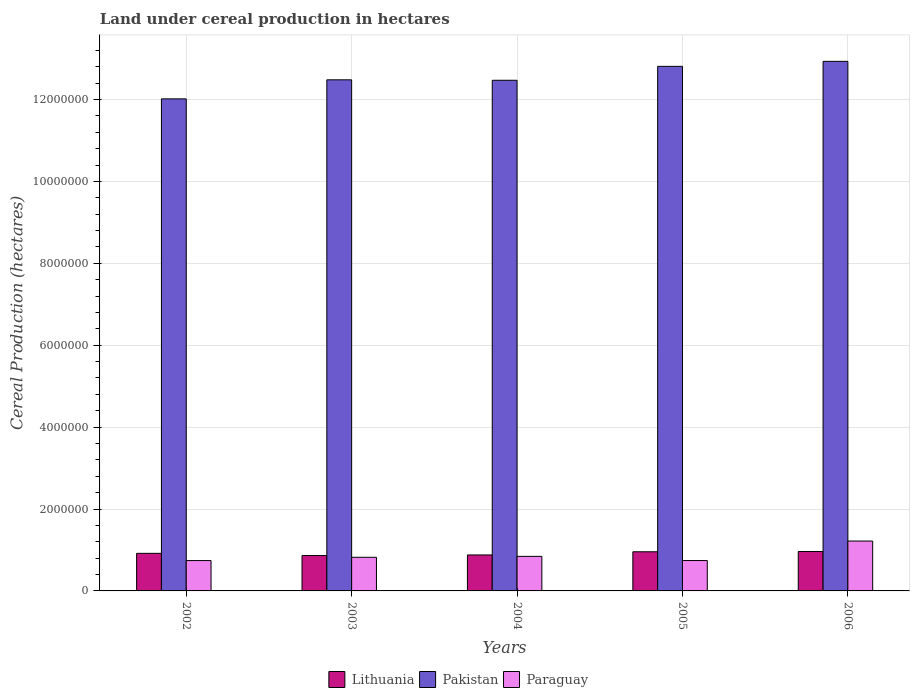How many different coloured bars are there?
Give a very brief answer. 3. How many bars are there on the 3rd tick from the left?
Provide a short and direct response. 3. In how many cases, is the number of bars for a given year not equal to the number of legend labels?
Your response must be concise. 0. What is the land under cereal production in Lithuania in 2002?
Your response must be concise. 9.18e+05. Across all years, what is the maximum land under cereal production in Paraguay?
Your answer should be very brief. 1.22e+06. Across all years, what is the minimum land under cereal production in Paraguay?
Your answer should be compact. 7.41e+05. In which year was the land under cereal production in Paraguay maximum?
Your answer should be very brief. 2006. What is the total land under cereal production in Pakistan in the graph?
Your response must be concise. 6.27e+07. What is the difference between the land under cereal production in Lithuania in 2004 and that in 2005?
Your answer should be compact. -7.76e+04. What is the difference between the land under cereal production in Lithuania in 2005 and the land under cereal production in Pakistan in 2006?
Make the answer very short. -1.20e+07. What is the average land under cereal production in Lithuania per year?
Offer a terse response. 9.16e+05. In the year 2003, what is the difference between the land under cereal production in Pakistan and land under cereal production in Paraguay?
Offer a very short reply. 1.17e+07. In how many years, is the land under cereal production in Lithuania greater than 12000000 hectares?
Make the answer very short. 0. What is the ratio of the land under cereal production in Pakistan in 2002 to that in 2005?
Your answer should be compact. 0.94. Is the land under cereal production in Pakistan in 2002 less than that in 2006?
Ensure brevity in your answer.  Yes. Is the difference between the land under cereal production in Pakistan in 2005 and 2006 greater than the difference between the land under cereal production in Paraguay in 2005 and 2006?
Provide a short and direct response. Yes. What is the difference between the highest and the second highest land under cereal production in Pakistan?
Give a very brief answer. 1.22e+05. What is the difference between the highest and the lowest land under cereal production in Lithuania?
Ensure brevity in your answer.  9.83e+04. What does the 3rd bar from the right in 2002 represents?
Give a very brief answer. Lithuania. How many years are there in the graph?
Give a very brief answer. 5. Does the graph contain any zero values?
Offer a terse response. No. Does the graph contain grids?
Ensure brevity in your answer.  Yes. How many legend labels are there?
Provide a short and direct response. 3. What is the title of the graph?
Give a very brief answer. Land under cereal production in hectares. Does "United Kingdom" appear as one of the legend labels in the graph?
Provide a succinct answer. No. What is the label or title of the X-axis?
Your answer should be compact. Years. What is the label or title of the Y-axis?
Give a very brief answer. Cereal Production (hectares). What is the Cereal Production (hectares) in Lithuania in 2002?
Ensure brevity in your answer.  9.18e+05. What is the Cereal Production (hectares) of Pakistan in 2002?
Provide a succinct answer. 1.20e+07. What is the Cereal Production (hectares) of Paraguay in 2002?
Keep it short and to the point. 7.41e+05. What is the Cereal Production (hectares) in Lithuania in 2003?
Your answer should be compact. 8.65e+05. What is the Cereal Production (hectares) in Pakistan in 2003?
Provide a succinct answer. 1.25e+07. What is the Cereal Production (hectares) of Paraguay in 2003?
Offer a very short reply. 8.21e+05. What is the Cereal Production (hectares) in Lithuania in 2004?
Provide a succinct answer. 8.78e+05. What is the Cereal Production (hectares) in Pakistan in 2004?
Make the answer very short. 1.25e+07. What is the Cereal Production (hectares) of Paraguay in 2004?
Your answer should be compact. 8.44e+05. What is the Cereal Production (hectares) of Lithuania in 2005?
Provide a succinct answer. 9.56e+05. What is the Cereal Production (hectares) of Pakistan in 2005?
Provide a succinct answer. 1.28e+07. What is the Cereal Production (hectares) of Paraguay in 2005?
Your answer should be very brief. 7.42e+05. What is the Cereal Production (hectares) in Lithuania in 2006?
Give a very brief answer. 9.63e+05. What is the Cereal Production (hectares) of Pakistan in 2006?
Make the answer very short. 1.29e+07. What is the Cereal Production (hectares) of Paraguay in 2006?
Your answer should be very brief. 1.22e+06. Across all years, what is the maximum Cereal Production (hectares) of Lithuania?
Your response must be concise. 9.63e+05. Across all years, what is the maximum Cereal Production (hectares) in Pakistan?
Keep it short and to the point. 1.29e+07. Across all years, what is the maximum Cereal Production (hectares) of Paraguay?
Offer a very short reply. 1.22e+06. Across all years, what is the minimum Cereal Production (hectares) in Lithuania?
Offer a terse response. 8.65e+05. Across all years, what is the minimum Cereal Production (hectares) in Pakistan?
Provide a succinct answer. 1.20e+07. Across all years, what is the minimum Cereal Production (hectares) in Paraguay?
Ensure brevity in your answer.  7.41e+05. What is the total Cereal Production (hectares) of Lithuania in the graph?
Keep it short and to the point. 4.58e+06. What is the total Cereal Production (hectares) in Pakistan in the graph?
Give a very brief answer. 6.27e+07. What is the total Cereal Production (hectares) of Paraguay in the graph?
Keep it short and to the point. 4.37e+06. What is the difference between the Cereal Production (hectares) of Lithuania in 2002 and that in 2003?
Give a very brief answer. 5.34e+04. What is the difference between the Cereal Production (hectares) of Pakistan in 2002 and that in 2003?
Provide a succinct answer. -4.65e+05. What is the difference between the Cereal Production (hectares) of Paraguay in 2002 and that in 2003?
Make the answer very short. -8.03e+04. What is the difference between the Cereal Production (hectares) in Lithuania in 2002 and that in 2004?
Give a very brief answer. 3.95e+04. What is the difference between the Cereal Production (hectares) in Pakistan in 2002 and that in 2004?
Your answer should be compact. -4.54e+05. What is the difference between the Cereal Production (hectares) of Paraguay in 2002 and that in 2004?
Offer a very short reply. -1.03e+05. What is the difference between the Cereal Production (hectares) in Lithuania in 2002 and that in 2005?
Make the answer very short. -3.81e+04. What is the difference between the Cereal Production (hectares) in Pakistan in 2002 and that in 2005?
Give a very brief answer. -7.94e+05. What is the difference between the Cereal Production (hectares) of Paraguay in 2002 and that in 2005?
Provide a short and direct response. -871. What is the difference between the Cereal Production (hectares) in Lithuania in 2002 and that in 2006?
Keep it short and to the point. -4.49e+04. What is the difference between the Cereal Production (hectares) of Pakistan in 2002 and that in 2006?
Offer a very short reply. -9.16e+05. What is the difference between the Cereal Production (hectares) of Paraguay in 2002 and that in 2006?
Keep it short and to the point. -4.77e+05. What is the difference between the Cereal Production (hectares) in Lithuania in 2003 and that in 2004?
Ensure brevity in your answer.  -1.39e+04. What is the difference between the Cereal Production (hectares) in Pakistan in 2003 and that in 2004?
Your answer should be very brief. 1.11e+04. What is the difference between the Cereal Production (hectares) of Paraguay in 2003 and that in 2004?
Your answer should be compact. -2.27e+04. What is the difference between the Cereal Production (hectares) of Lithuania in 2003 and that in 2005?
Give a very brief answer. -9.15e+04. What is the difference between the Cereal Production (hectares) in Pakistan in 2003 and that in 2005?
Ensure brevity in your answer.  -3.29e+05. What is the difference between the Cereal Production (hectares) of Paraguay in 2003 and that in 2005?
Your response must be concise. 7.94e+04. What is the difference between the Cereal Production (hectares) of Lithuania in 2003 and that in 2006?
Make the answer very short. -9.83e+04. What is the difference between the Cereal Production (hectares) in Pakistan in 2003 and that in 2006?
Provide a short and direct response. -4.51e+05. What is the difference between the Cereal Production (hectares) of Paraguay in 2003 and that in 2006?
Your answer should be very brief. -3.97e+05. What is the difference between the Cereal Production (hectares) of Lithuania in 2004 and that in 2005?
Provide a succinct answer. -7.76e+04. What is the difference between the Cereal Production (hectares) of Pakistan in 2004 and that in 2005?
Provide a short and direct response. -3.40e+05. What is the difference between the Cereal Production (hectares) of Paraguay in 2004 and that in 2005?
Your answer should be compact. 1.02e+05. What is the difference between the Cereal Production (hectares) in Lithuania in 2004 and that in 2006?
Your response must be concise. -8.44e+04. What is the difference between the Cereal Production (hectares) of Pakistan in 2004 and that in 2006?
Keep it short and to the point. -4.62e+05. What is the difference between the Cereal Production (hectares) in Paraguay in 2004 and that in 2006?
Your answer should be very brief. -3.74e+05. What is the difference between the Cereal Production (hectares) in Lithuania in 2005 and that in 2006?
Your response must be concise. -6800. What is the difference between the Cereal Production (hectares) in Pakistan in 2005 and that in 2006?
Make the answer very short. -1.22e+05. What is the difference between the Cereal Production (hectares) in Paraguay in 2005 and that in 2006?
Provide a short and direct response. -4.76e+05. What is the difference between the Cereal Production (hectares) in Lithuania in 2002 and the Cereal Production (hectares) in Pakistan in 2003?
Your answer should be very brief. -1.16e+07. What is the difference between the Cereal Production (hectares) of Lithuania in 2002 and the Cereal Production (hectares) of Paraguay in 2003?
Ensure brevity in your answer.  9.67e+04. What is the difference between the Cereal Production (hectares) in Pakistan in 2002 and the Cereal Production (hectares) in Paraguay in 2003?
Give a very brief answer. 1.12e+07. What is the difference between the Cereal Production (hectares) of Lithuania in 2002 and the Cereal Production (hectares) of Pakistan in 2004?
Offer a very short reply. -1.16e+07. What is the difference between the Cereal Production (hectares) of Lithuania in 2002 and the Cereal Production (hectares) of Paraguay in 2004?
Your answer should be very brief. 7.41e+04. What is the difference between the Cereal Production (hectares) of Pakistan in 2002 and the Cereal Production (hectares) of Paraguay in 2004?
Ensure brevity in your answer.  1.12e+07. What is the difference between the Cereal Production (hectares) of Lithuania in 2002 and the Cereal Production (hectares) of Pakistan in 2005?
Provide a succinct answer. -1.19e+07. What is the difference between the Cereal Production (hectares) in Lithuania in 2002 and the Cereal Production (hectares) in Paraguay in 2005?
Provide a succinct answer. 1.76e+05. What is the difference between the Cereal Production (hectares) in Pakistan in 2002 and the Cereal Production (hectares) in Paraguay in 2005?
Your answer should be compact. 1.13e+07. What is the difference between the Cereal Production (hectares) of Lithuania in 2002 and the Cereal Production (hectares) of Pakistan in 2006?
Ensure brevity in your answer.  -1.20e+07. What is the difference between the Cereal Production (hectares) in Lithuania in 2002 and the Cereal Production (hectares) in Paraguay in 2006?
Offer a very short reply. -3.00e+05. What is the difference between the Cereal Production (hectares) of Pakistan in 2002 and the Cereal Production (hectares) of Paraguay in 2006?
Make the answer very short. 1.08e+07. What is the difference between the Cereal Production (hectares) in Lithuania in 2003 and the Cereal Production (hectares) in Pakistan in 2004?
Give a very brief answer. -1.16e+07. What is the difference between the Cereal Production (hectares) in Lithuania in 2003 and the Cereal Production (hectares) in Paraguay in 2004?
Give a very brief answer. 2.07e+04. What is the difference between the Cereal Production (hectares) in Pakistan in 2003 and the Cereal Production (hectares) in Paraguay in 2004?
Offer a very short reply. 1.16e+07. What is the difference between the Cereal Production (hectares) in Lithuania in 2003 and the Cereal Production (hectares) in Pakistan in 2005?
Give a very brief answer. -1.19e+07. What is the difference between the Cereal Production (hectares) of Lithuania in 2003 and the Cereal Production (hectares) of Paraguay in 2005?
Your response must be concise. 1.23e+05. What is the difference between the Cereal Production (hectares) in Pakistan in 2003 and the Cereal Production (hectares) in Paraguay in 2005?
Give a very brief answer. 1.17e+07. What is the difference between the Cereal Production (hectares) in Lithuania in 2003 and the Cereal Production (hectares) in Pakistan in 2006?
Give a very brief answer. -1.21e+07. What is the difference between the Cereal Production (hectares) in Lithuania in 2003 and the Cereal Production (hectares) in Paraguay in 2006?
Offer a terse response. -3.54e+05. What is the difference between the Cereal Production (hectares) in Pakistan in 2003 and the Cereal Production (hectares) in Paraguay in 2006?
Keep it short and to the point. 1.13e+07. What is the difference between the Cereal Production (hectares) in Lithuania in 2004 and the Cereal Production (hectares) in Pakistan in 2005?
Make the answer very short. -1.19e+07. What is the difference between the Cereal Production (hectares) in Lithuania in 2004 and the Cereal Production (hectares) in Paraguay in 2005?
Keep it short and to the point. 1.37e+05. What is the difference between the Cereal Production (hectares) of Pakistan in 2004 and the Cereal Production (hectares) of Paraguay in 2005?
Offer a terse response. 1.17e+07. What is the difference between the Cereal Production (hectares) in Lithuania in 2004 and the Cereal Production (hectares) in Pakistan in 2006?
Your answer should be compact. -1.21e+07. What is the difference between the Cereal Production (hectares) of Lithuania in 2004 and the Cereal Production (hectares) of Paraguay in 2006?
Your response must be concise. -3.40e+05. What is the difference between the Cereal Production (hectares) of Pakistan in 2004 and the Cereal Production (hectares) of Paraguay in 2006?
Make the answer very short. 1.13e+07. What is the difference between the Cereal Production (hectares) in Lithuania in 2005 and the Cereal Production (hectares) in Pakistan in 2006?
Make the answer very short. -1.20e+07. What is the difference between the Cereal Production (hectares) in Lithuania in 2005 and the Cereal Production (hectares) in Paraguay in 2006?
Make the answer very short. -2.62e+05. What is the difference between the Cereal Production (hectares) in Pakistan in 2005 and the Cereal Production (hectares) in Paraguay in 2006?
Offer a very short reply. 1.16e+07. What is the average Cereal Production (hectares) in Lithuania per year?
Provide a succinct answer. 9.16e+05. What is the average Cereal Production (hectares) of Pakistan per year?
Provide a short and direct response. 1.25e+07. What is the average Cereal Production (hectares) in Paraguay per year?
Ensure brevity in your answer.  8.73e+05. In the year 2002, what is the difference between the Cereal Production (hectares) of Lithuania and Cereal Production (hectares) of Pakistan?
Give a very brief answer. -1.11e+07. In the year 2002, what is the difference between the Cereal Production (hectares) of Lithuania and Cereal Production (hectares) of Paraguay?
Ensure brevity in your answer.  1.77e+05. In the year 2002, what is the difference between the Cereal Production (hectares) of Pakistan and Cereal Production (hectares) of Paraguay?
Provide a succinct answer. 1.13e+07. In the year 2003, what is the difference between the Cereal Production (hectares) in Lithuania and Cereal Production (hectares) in Pakistan?
Your answer should be very brief. -1.16e+07. In the year 2003, what is the difference between the Cereal Production (hectares) of Lithuania and Cereal Production (hectares) of Paraguay?
Your answer should be very brief. 4.33e+04. In the year 2003, what is the difference between the Cereal Production (hectares) in Pakistan and Cereal Production (hectares) in Paraguay?
Provide a succinct answer. 1.17e+07. In the year 2004, what is the difference between the Cereal Production (hectares) in Lithuania and Cereal Production (hectares) in Pakistan?
Your answer should be compact. -1.16e+07. In the year 2004, what is the difference between the Cereal Production (hectares) in Lithuania and Cereal Production (hectares) in Paraguay?
Make the answer very short. 3.46e+04. In the year 2004, what is the difference between the Cereal Production (hectares) in Pakistan and Cereal Production (hectares) in Paraguay?
Make the answer very short. 1.16e+07. In the year 2005, what is the difference between the Cereal Production (hectares) in Lithuania and Cereal Production (hectares) in Pakistan?
Your answer should be very brief. -1.19e+07. In the year 2005, what is the difference between the Cereal Production (hectares) in Lithuania and Cereal Production (hectares) in Paraguay?
Offer a very short reply. 2.14e+05. In the year 2005, what is the difference between the Cereal Production (hectares) in Pakistan and Cereal Production (hectares) in Paraguay?
Make the answer very short. 1.21e+07. In the year 2006, what is the difference between the Cereal Production (hectares) in Lithuania and Cereal Production (hectares) in Pakistan?
Make the answer very short. -1.20e+07. In the year 2006, what is the difference between the Cereal Production (hectares) of Lithuania and Cereal Production (hectares) of Paraguay?
Provide a succinct answer. -2.55e+05. In the year 2006, what is the difference between the Cereal Production (hectares) in Pakistan and Cereal Production (hectares) in Paraguay?
Provide a short and direct response. 1.17e+07. What is the ratio of the Cereal Production (hectares) in Lithuania in 2002 to that in 2003?
Make the answer very short. 1.06. What is the ratio of the Cereal Production (hectares) in Pakistan in 2002 to that in 2003?
Ensure brevity in your answer.  0.96. What is the ratio of the Cereal Production (hectares) of Paraguay in 2002 to that in 2003?
Make the answer very short. 0.9. What is the ratio of the Cereal Production (hectares) of Lithuania in 2002 to that in 2004?
Your answer should be very brief. 1.04. What is the ratio of the Cereal Production (hectares) of Pakistan in 2002 to that in 2004?
Ensure brevity in your answer.  0.96. What is the ratio of the Cereal Production (hectares) in Paraguay in 2002 to that in 2004?
Your answer should be very brief. 0.88. What is the ratio of the Cereal Production (hectares) of Lithuania in 2002 to that in 2005?
Provide a short and direct response. 0.96. What is the ratio of the Cereal Production (hectares) of Pakistan in 2002 to that in 2005?
Your answer should be compact. 0.94. What is the ratio of the Cereal Production (hectares) of Lithuania in 2002 to that in 2006?
Ensure brevity in your answer.  0.95. What is the ratio of the Cereal Production (hectares) of Pakistan in 2002 to that in 2006?
Your response must be concise. 0.93. What is the ratio of the Cereal Production (hectares) of Paraguay in 2002 to that in 2006?
Your response must be concise. 0.61. What is the ratio of the Cereal Production (hectares) in Lithuania in 2003 to that in 2004?
Your response must be concise. 0.98. What is the ratio of the Cereal Production (hectares) of Paraguay in 2003 to that in 2004?
Provide a succinct answer. 0.97. What is the ratio of the Cereal Production (hectares) of Lithuania in 2003 to that in 2005?
Ensure brevity in your answer.  0.9. What is the ratio of the Cereal Production (hectares) in Pakistan in 2003 to that in 2005?
Your response must be concise. 0.97. What is the ratio of the Cereal Production (hectares) of Paraguay in 2003 to that in 2005?
Offer a terse response. 1.11. What is the ratio of the Cereal Production (hectares) of Lithuania in 2003 to that in 2006?
Make the answer very short. 0.9. What is the ratio of the Cereal Production (hectares) of Pakistan in 2003 to that in 2006?
Offer a terse response. 0.97. What is the ratio of the Cereal Production (hectares) in Paraguay in 2003 to that in 2006?
Offer a very short reply. 0.67. What is the ratio of the Cereal Production (hectares) in Lithuania in 2004 to that in 2005?
Your answer should be compact. 0.92. What is the ratio of the Cereal Production (hectares) of Pakistan in 2004 to that in 2005?
Offer a terse response. 0.97. What is the ratio of the Cereal Production (hectares) in Paraguay in 2004 to that in 2005?
Offer a very short reply. 1.14. What is the ratio of the Cereal Production (hectares) in Lithuania in 2004 to that in 2006?
Provide a succinct answer. 0.91. What is the ratio of the Cereal Production (hectares) in Paraguay in 2004 to that in 2006?
Make the answer very short. 0.69. What is the ratio of the Cereal Production (hectares) of Lithuania in 2005 to that in 2006?
Provide a succinct answer. 0.99. What is the ratio of the Cereal Production (hectares) of Pakistan in 2005 to that in 2006?
Your answer should be very brief. 0.99. What is the ratio of the Cereal Production (hectares) in Paraguay in 2005 to that in 2006?
Keep it short and to the point. 0.61. What is the difference between the highest and the second highest Cereal Production (hectares) in Lithuania?
Keep it short and to the point. 6800. What is the difference between the highest and the second highest Cereal Production (hectares) of Pakistan?
Ensure brevity in your answer.  1.22e+05. What is the difference between the highest and the second highest Cereal Production (hectares) of Paraguay?
Offer a very short reply. 3.74e+05. What is the difference between the highest and the lowest Cereal Production (hectares) of Lithuania?
Make the answer very short. 9.83e+04. What is the difference between the highest and the lowest Cereal Production (hectares) in Pakistan?
Provide a short and direct response. 9.16e+05. What is the difference between the highest and the lowest Cereal Production (hectares) in Paraguay?
Keep it short and to the point. 4.77e+05. 